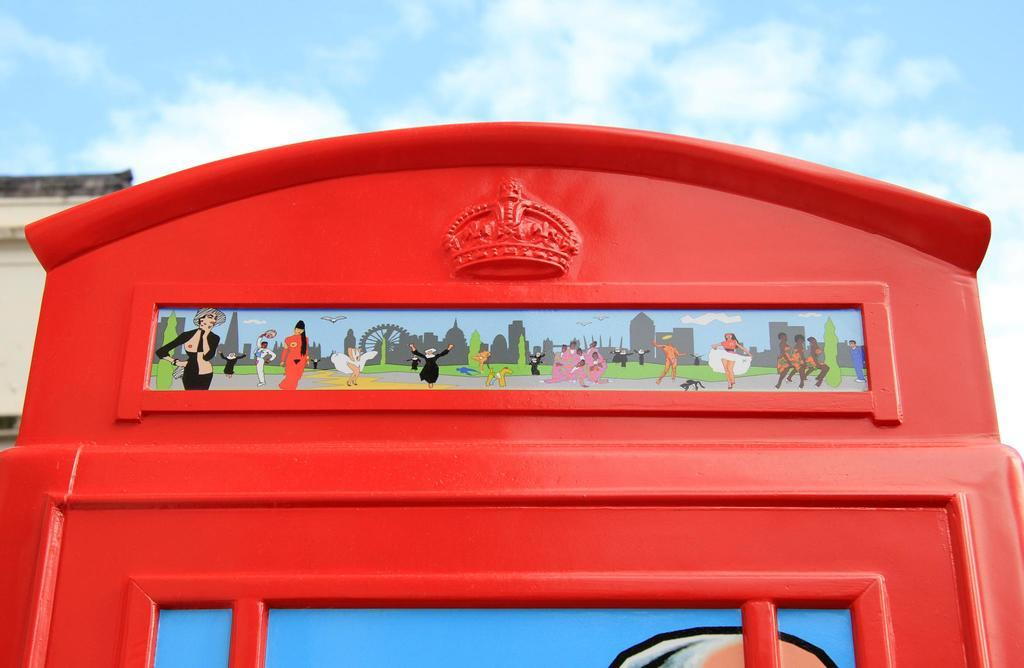What type of structure is depicted in the image? There is an architecture in the image. What is the color of the architecture? The architecture is red in color. What other elements can be seen in the image besides the architecture? There are cartoon images in the image. What can be seen in the background of the image? The sky is visible in the background of the image. What type of guitar can be seen in the image? There is no guitar present in the image. How many chickens are visible in the image? There are no chickens present in the image. 